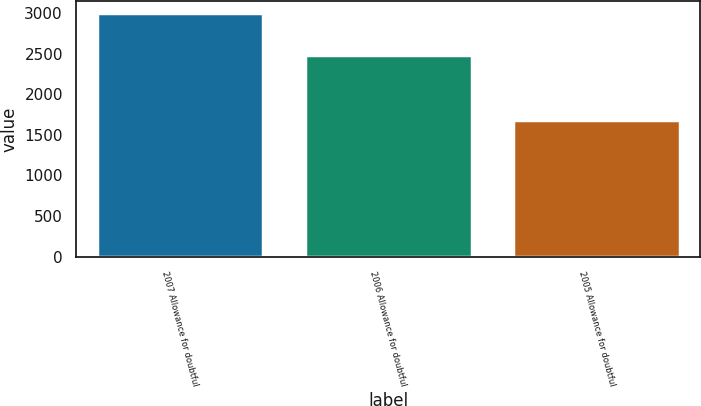Convert chart to OTSL. <chart><loc_0><loc_0><loc_500><loc_500><bar_chart><fcel>2007 Allowance for doubtful<fcel>2006 Allowance for doubtful<fcel>2005 Allowance for doubtful<nl><fcel>2998<fcel>2481<fcel>1686<nl></chart> 